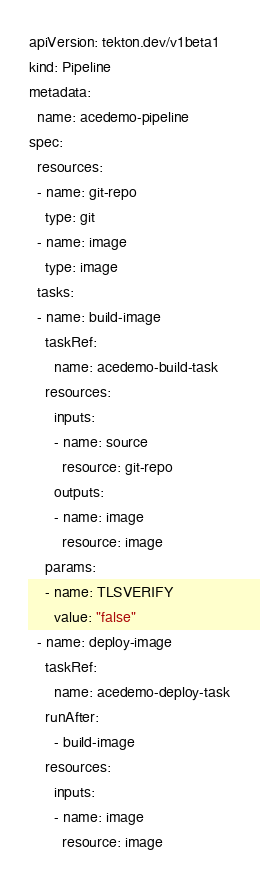Convert code to text. <code><loc_0><loc_0><loc_500><loc_500><_YAML_>apiVersion: tekton.dev/v1beta1
kind: Pipeline
metadata:
  name: acedemo-pipeline
spec:
  resources:
  - name: git-repo
    type: git
  - name: image
    type: image
  tasks:
  - name: build-image
    taskRef:
      name: acedemo-build-task
    resources:
      inputs:
      - name: source
        resource: git-repo
      outputs:
      - name: image
        resource: image
    params:
    - name: TLSVERIFY
      value: "false"
  - name: deploy-image
    taskRef:
      name: acedemo-deploy-task
    runAfter:
      - build-image
    resources:
      inputs:
      - name: image
        resource: image
</code> 